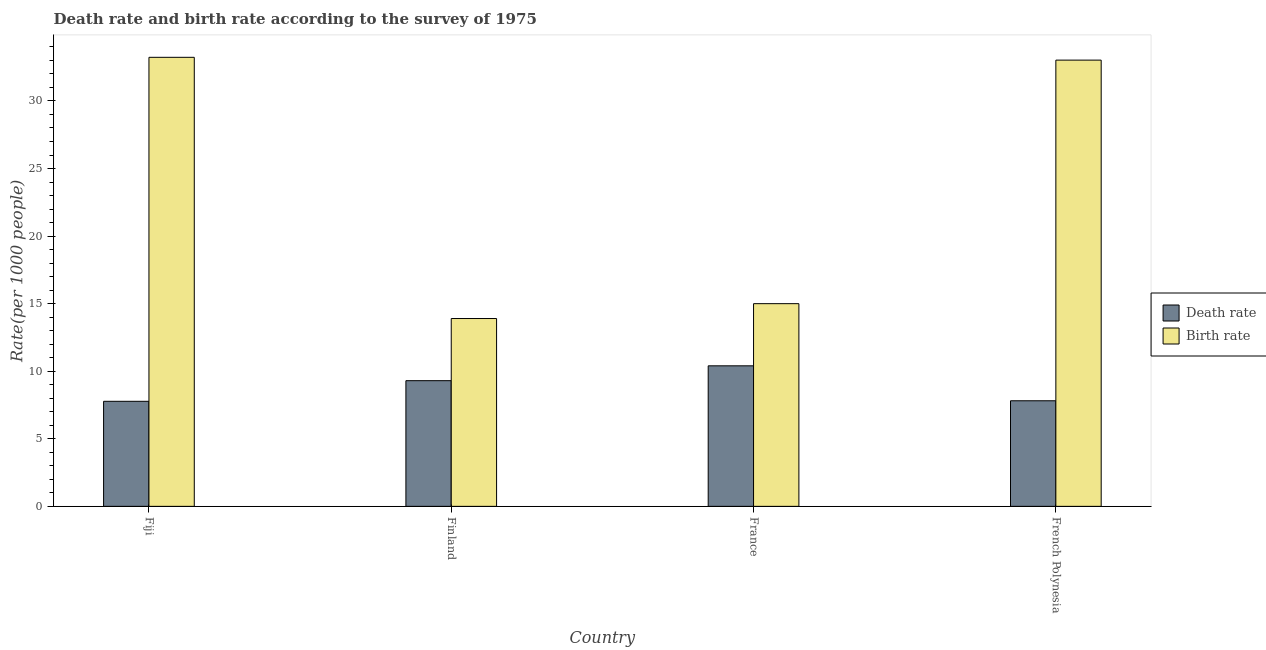How many different coloured bars are there?
Offer a terse response. 2. How many bars are there on the 2nd tick from the left?
Ensure brevity in your answer.  2. In how many cases, is the number of bars for a given country not equal to the number of legend labels?
Your answer should be compact. 0. What is the death rate in French Polynesia?
Make the answer very short. 7.81. Across all countries, what is the maximum death rate?
Your answer should be very brief. 10.4. Across all countries, what is the minimum death rate?
Your response must be concise. 7.77. In which country was the death rate minimum?
Offer a very short reply. Fiji. What is the total death rate in the graph?
Your response must be concise. 35.29. What is the difference between the birth rate in Finland and that in French Polynesia?
Keep it short and to the point. -19.12. What is the difference between the death rate in French Polynesia and the birth rate in Finland?
Provide a succinct answer. -6.09. What is the average death rate per country?
Make the answer very short. 8.82. What is the difference between the birth rate and death rate in France?
Offer a very short reply. 4.6. What is the ratio of the death rate in Fiji to that in French Polynesia?
Provide a short and direct response. 0.99. What is the difference between the highest and the second highest birth rate?
Ensure brevity in your answer.  0.21. What is the difference between the highest and the lowest death rate?
Offer a very short reply. 2.63. Is the sum of the birth rate in France and French Polynesia greater than the maximum death rate across all countries?
Provide a succinct answer. Yes. What does the 2nd bar from the left in Fiji represents?
Offer a terse response. Birth rate. What does the 2nd bar from the right in France represents?
Offer a terse response. Death rate. How many countries are there in the graph?
Your response must be concise. 4. What is the difference between two consecutive major ticks on the Y-axis?
Your answer should be very brief. 5. Are the values on the major ticks of Y-axis written in scientific E-notation?
Your answer should be very brief. No. Where does the legend appear in the graph?
Your response must be concise. Center right. How many legend labels are there?
Your answer should be very brief. 2. How are the legend labels stacked?
Your answer should be very brief. Vertical. What is the title of the graph?
Your response must be concise. Death rate and birth rate according to the survey of 1975. Does "Short-term debt" appear as one of the legend labels in the graph?
Your answer should be compact. No. What is the label or title of the X-axis?
Your answer should be compact. Country. What is the label or title of the Y-axis?
Your answer should be compact. Rate(per 1000 people). What is the Rate(per 1000 people) of Death rate in Fiji?
Your answer should be compact. 7.77. What is the Rate(per 1000 people) of Birth rate in Fiji?
Keep it short and to the point. 33.23. What is the Rate(per 1000 people) of Birth rate in France?
Offer a very short reply. 15. What is the Rate(per 1000 people) of Death rate in French Polynesia?
Make the answer very short. 7.81. What is the Rate(per 1000 people) of Birth rate in French Polynesia?
Your answer should be very brief. 33.02. Across all countries, what is the maximum Rate(per 1000 people) of Birth rate?
Keep it short and to the point. 33.23. Across all countries, what is the minimum Rate(per 1000 people) of Death rate?
Provide a short and direct response. 7.77. What is the total Rate(per 1000 people) of Death rate in the graph?
Provide a short and direct response. 35.29. What is the total Rate(per 1000 people) in Birth rate in the graph?
Offer a very short reply. 95.15. What is the difference between the Rate(per 1000 people) of Death rate in Fiji and that in Finland?
Provide a succinct answer. -1.53. What is the difference between the Rate(per 1000 people) in Birth rate in Fiji and that in Finland?
Ensure brevity in your answer.  19.33. What is the difference between the Rate(per 1000 people) of Death rate in Fiji and that in France?
Make the answer very short. -2.63. What is the difference between the Rate(per 1000 people) of Birth rate in Fiji and that in France?
Your answer should be very brief. 18.23. What is the difference between the Rate(per 1000 people) in Death rate in Fiji and that in French Polynesia?
Give a very brief answer. -0.04. What is the difference between the Rate(per 1000 people) of Birth rate in Fiji and that in French Polynesia?
Keep it short and to the point. 0.21. What is the difference between the Rate(per 1000 people) in Death rate in Finland and that in France?
Ensure brevity in your answer.  -1.1. What is the difference between the Rate(per 1000 people) of Death rate in Finland and that in French Polynesia?
Your answer should be very brief. 1.49. What is the difference between the Rate(per 1000 people) of Birth rate in Finland and that in French Polynesia?
Offer a very short reply. -19.12. What is the difference between the Rate(per 1000 people) of Death rate in France and that in French Polynesia?
Give a very brief answer. 2.59. What is the difference between the Rate(per 1000 people) in Birth rate in France and that in French Polynesia?
Offer a terse response. -18.02. What is the difference between the Rate(per 1000 people) in Death rate in Fiji and the Rate(per 1000 people) in Birth rate in Finland?
Provide a succinct answer. -6.13. What is the difference between the Rate(per 1000 people) in Death rate in Fiji and the Rate(per 1000 people) in Birth rate in France?
Offer a terse response. -7.23. What is the difference between the Rate(per 1000 people) in Death rate in Fiji and the Rate(per 1000 people) in Birth rate in French Polynesia?
Your response must be concise. -25.25. What is the difference between the Rate(per 1000 people) of Death rate in Finland and the Rate(per 1000 people) of Birth rate in France?
Offer a very short reply. -5.7. What is the difference between the Rate(per 1000 people) of Death rate in Finland and the Rate(per 1000 people) of Birth rate in French Polynesia?
Offer a terse response. -23.72. What is the difference between the Rate(per 1000 people) in Death rate in France and the Rate(per 1000 people) in Birth rate in French Polynesia?
Provide a short and direct response. -22.62. What is the average Rate(per 1000 people) of Death rate per country?
Your answer should be very brief. 8.82. What is the average Rate(per 1000 people) of Birth rate per country?
Your answer should be very brief. 23.79. What is the difference between the Rate(per 1000 people) of Death rate and Rate(per 1000 people) of Birth rate in Fiji?
Your answer should be very brief. -25.46. What is the difference between the Rate(per 1000 people) in Death rate and Rate(per 1000 people) in Birth rate in France?
Ensure brevity in your answer.  -4.6. What is the difference between the Rate(per 1000 people) of Death rate and Rate(per 1000 people) of Birth rate in French Polynesia?
Keep it short and to the point. -25.21. What is the ratio of the Rate(per 1000 people) in Death rate in Fiji to that in Finland?
Offer a terse response. 0.84. What is the ratio of the Rate(per 1000 people) in Birth rate in Fiji to that in Finland?
Keep it short and to the point. 2.39. What is the ratio of the Rate(per 1000 people) in Death rate in Fiji to that in France?
Ensure brevity in your answer.  0.75. What is the ratio of the Rate(per 1000 people) in Birth rate in Fiji to that in France?
Provide a succinct answer. 2.22. What is the ratio of the Rate(per 1000 people) in Death rate in Finland to that in France?
Your answer should be compact. 0.89. What is the ratio of the Rate(per 1000 people) in Birth rate in Finland to that in France?
Your answer should be compact. 0.93. What is the ratio of the Rate(per 1000 people) of Death rate in Finland to that in French Polynesia?
Your response must be concise. 1.19. What is the ratio of the Rate(per 1000 people) in Birth rate in Finland to that in French Polynesia?
Offer a very short reply. 0.42. What is the ratio of the Rate(per 1000 people) in Death rate in France to that in French Polynesia?
Offer a terse response. 1.33. What is the ratio of the Rate(per 1000 people) of Birth rate in France to that in French Polynesia?
Offer a terse response. 0.45. What is the difference between the highest and the second highest Rate(per 1000 people) of Death rate?
Provide a succinct answer. 1.1. What is the difference between the highest and the second highest Rate(per 1000 people) of Birth rate?
Provide a succinct answer. 0.21. What is the difference between the highest and the lowest Rate(per 1000 people) in Death rate?
Make the answer very short. 2.63. What is the difference between the highest and the lowest Rate(per 1000 people) of Birth rate?
Make the answer very short. 19.33. 